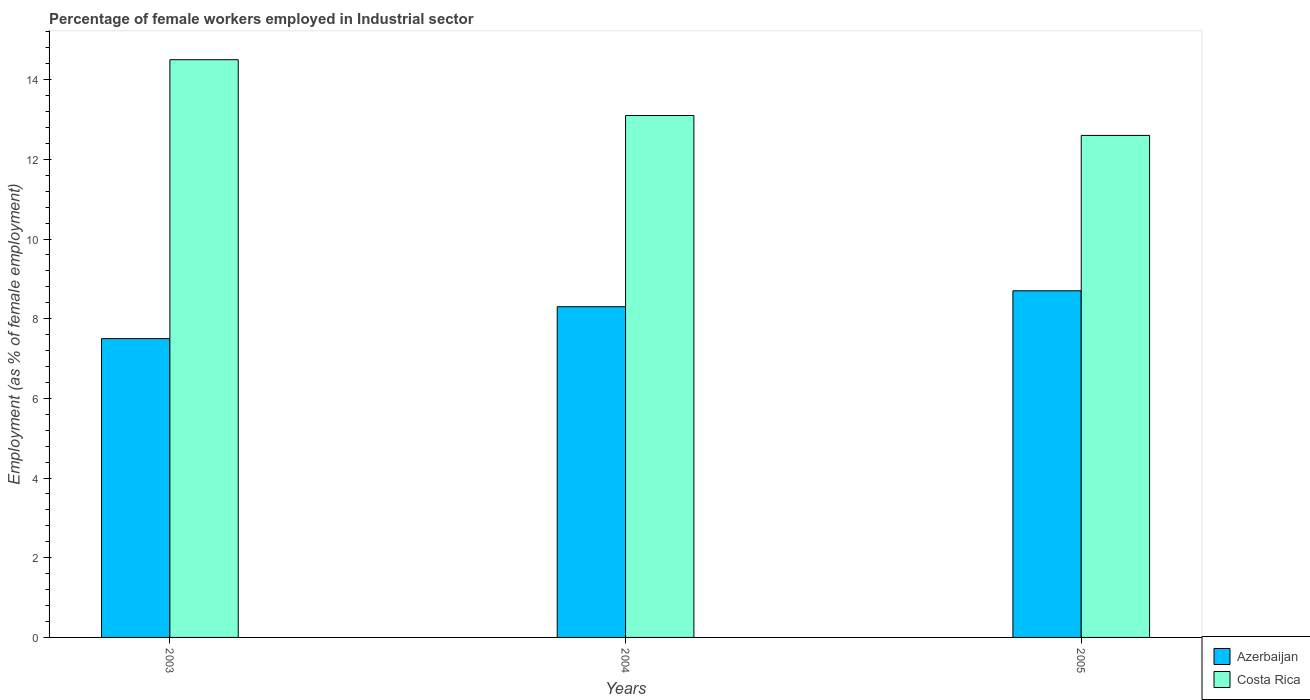How many groups of bars are there?
Provide a short and direct response. 3. What is the percentage of females employed in Industrial sector in Azerbaijan in 2005?
Give a very brief answer. 8.7. Across all years, what is the maximum percentage of females employed in Industrial sector in Costa Rica?
Ensure brevity in your answer.  14.5. Across all years, what is the minimum percentage of females employed in Industrial sector in Costa Rica?
Your answer should be compact. 12.6. In which year was the percentage of females employed in Industrial sector in Costa Rica maximum?
Your response must be concise. 2003. In which year was the percentage of females employed in Industrial sector in Costa Rica minimum?
Your answer should be compact. 2005. What is the total percentage of females employed in Industrial sector in Azerbaijan in the graph?
Your answer should be very brief. 24.5. What is the difference between the percentage of females employed in Industrial sector in Costa Rica in 2004 and that in 2005?
Ensure brevity in your answer.  0.5. What is the difference between the percentage of females employed in Industrial sector in Azerbaijan in 2005 and the percentage of females employed in Industrial sector in Costa Rica in 2004?
Provide a succinct answer. -4.4. What is the average percentage of females employed in Industrial sector in Azerbaijan per year?
Make the answer very short. 8.17. In the year 2005, what is the difference between the percentage of females employed in Industrial sector in Costa Rica and percentage of females employed in Industrial sector in Azerbaijan?
Offer a very short reply. 3.9. In how many years, is the percentage of females employed in Industrial sector in Costa Rica greater than 1.6 %?
Give a very brief answer. 3. What is the ratio of the percentage of females employed in Industrial sector in Costa Rica in 2004 to that in 2005?
Ensure brevity in your answer.  1.04. What is the difference between the highest and the second highest percentage of females employed in Industrial sector in Azerbaijan?
Your answer should be very brief. 0.4. What is the difference between the highest and the lowest percentage of females employed in Industrial sector in Costa Rica?
Provide a short and direct response. 1.9. What does the 2nd bar from the left in 2005 represents?
Give a very brief answer. Costa Rica. What does the 2nd bar from the right in 2005 represents?
Provide a succinct answer. Azerbaijan. Are all the bars in the graph horizontal?
Provide a succinct answer. No. How many years are there in the graph?
Offer a very short reply. 3. Does the graph contain any zero values?
Keep it short and to the point. No. Does the graph contain grids?
Keep it short and to the point. No. Where does the legend appear in the graph?
Offer a terse response. Bottom right. How many legend labels are there?
Keep it short and to the point. 2. How are the legend labels stacked?
Keep it short and to the point. Vertical. What is the title of the graph?
Keep it short and to the point. Percentage of female workers employed in Industrial sector. What is the label or title of the Y-axis?
Ensure brevity in your answer.  Employment (as % of female employment). What is the Employment (as % of female employment) of Costa Rica in 2003?
Make the answer very short. 14.5. What is the Employment (as % of female employment) of Azerbaijan in 2004?
Your answer should be very brief. 8.3. What is the Employment (as % of female employment) in Costa Rica in 2004?
Your answer should be compact. 13.1. What is the Employment (as % of female employment) of Azerbaijan in 2005?
Keep it short and to the point. 8.7. What is the Employment (as % of female employment) of Costa Rica in 2005?
Provide a succinct answer. 12.6. Across all years, what is the maximum Employment (as % of female employment) of Azerbaijan?
Offer a terse response. 8.7. Across all years, what is the maximum Employment (as % of female employment) in Costa Rica?
Offer a very short reply. 14.5. Across all years, what is the minimum Employment (as % of female employment) in Azerbaijan?
Provide a short and direct response. 7.5. Across all years, what is the minimum Employment (as % of female employment) of Costa Rica?
Keep it short and to the point. 12.6. What is the total Employment (as % of female employment) of Costa Rica in the graph?
Offer a very short reply. 40.2. What is the difference between the Employment (as % of female employment) of Azerbaijan in 2003 and that in 2004?
Provide a succinct answer. -0.8. What is the difference between the Employment (as % of female employment) in Costa Rica in 2003 and that in 2004?
Provide a succinct answer. 1.4. What is the difference between the Employment (as % of female employment) in Azerbaijan in 2004 and that in 2005?
Provide a short and direct response. -0.4. What is the difference between the Employment (as % of female employment) of Azerbaijan in 2003 and the Employment (as % of female employment) of Costa Rica in 2005?
Your response must be concise. -5.1. What is the average Employment (as % of female employment) in Azerbaijan per year?
Offer a terse response. 8.17. What is the average Employment (as % of female employment) of Costa Rica per year?
Provide a succinct answer. 13.4. In the year 2005, what is the difference between the Employment (as % of female employment) in Azerbaijan and Employment (as % of female employment) in Costa Rica?
Keep it short and to the point. -3.9. What is the ratio of the Employment (as % of female employment) of Azerbaijan in 2003 to that in 2004?
Give a very brief answer. 0.9. What is the ratio of the Employment (as % of female employment) of Costa Rica in 2003 to that in 2004?
Keep it short and to the point. 1.11. What is the ratio of the Employment (as % of female employment) in Azerbaijan in 2003 to that in 2005?
Offer a terse response. 0.86. What is the ratio of the Employment (as % of female employment) in Costa Rica in 2003 to that in 2005?
Give a very brief answer. 1.15. What is the ratio of the Employment (as % of female employment) of Azerbaijan in 2004 to that in 2005?
Your answer should be very brief. 0.95. What is the ratio of the Employment (as % of female employment) of Costa Rica in 2004 to that in 2005?
Provide a succinct answer. 1.04. What is the difference between the highest and the second highest Employment (as % of female employment) of Azerbaijan?
Keep it short and to the point. 0.4. What is the difference between the highest and the second highest Employment (as % of female employment) in Costa Rica?
Provide a short and direct response. 1.4. What is the difference between the highest and the lowest Employment (as % of female employment) in Azerbaijan?
Provide a short and direct response. 1.2. 